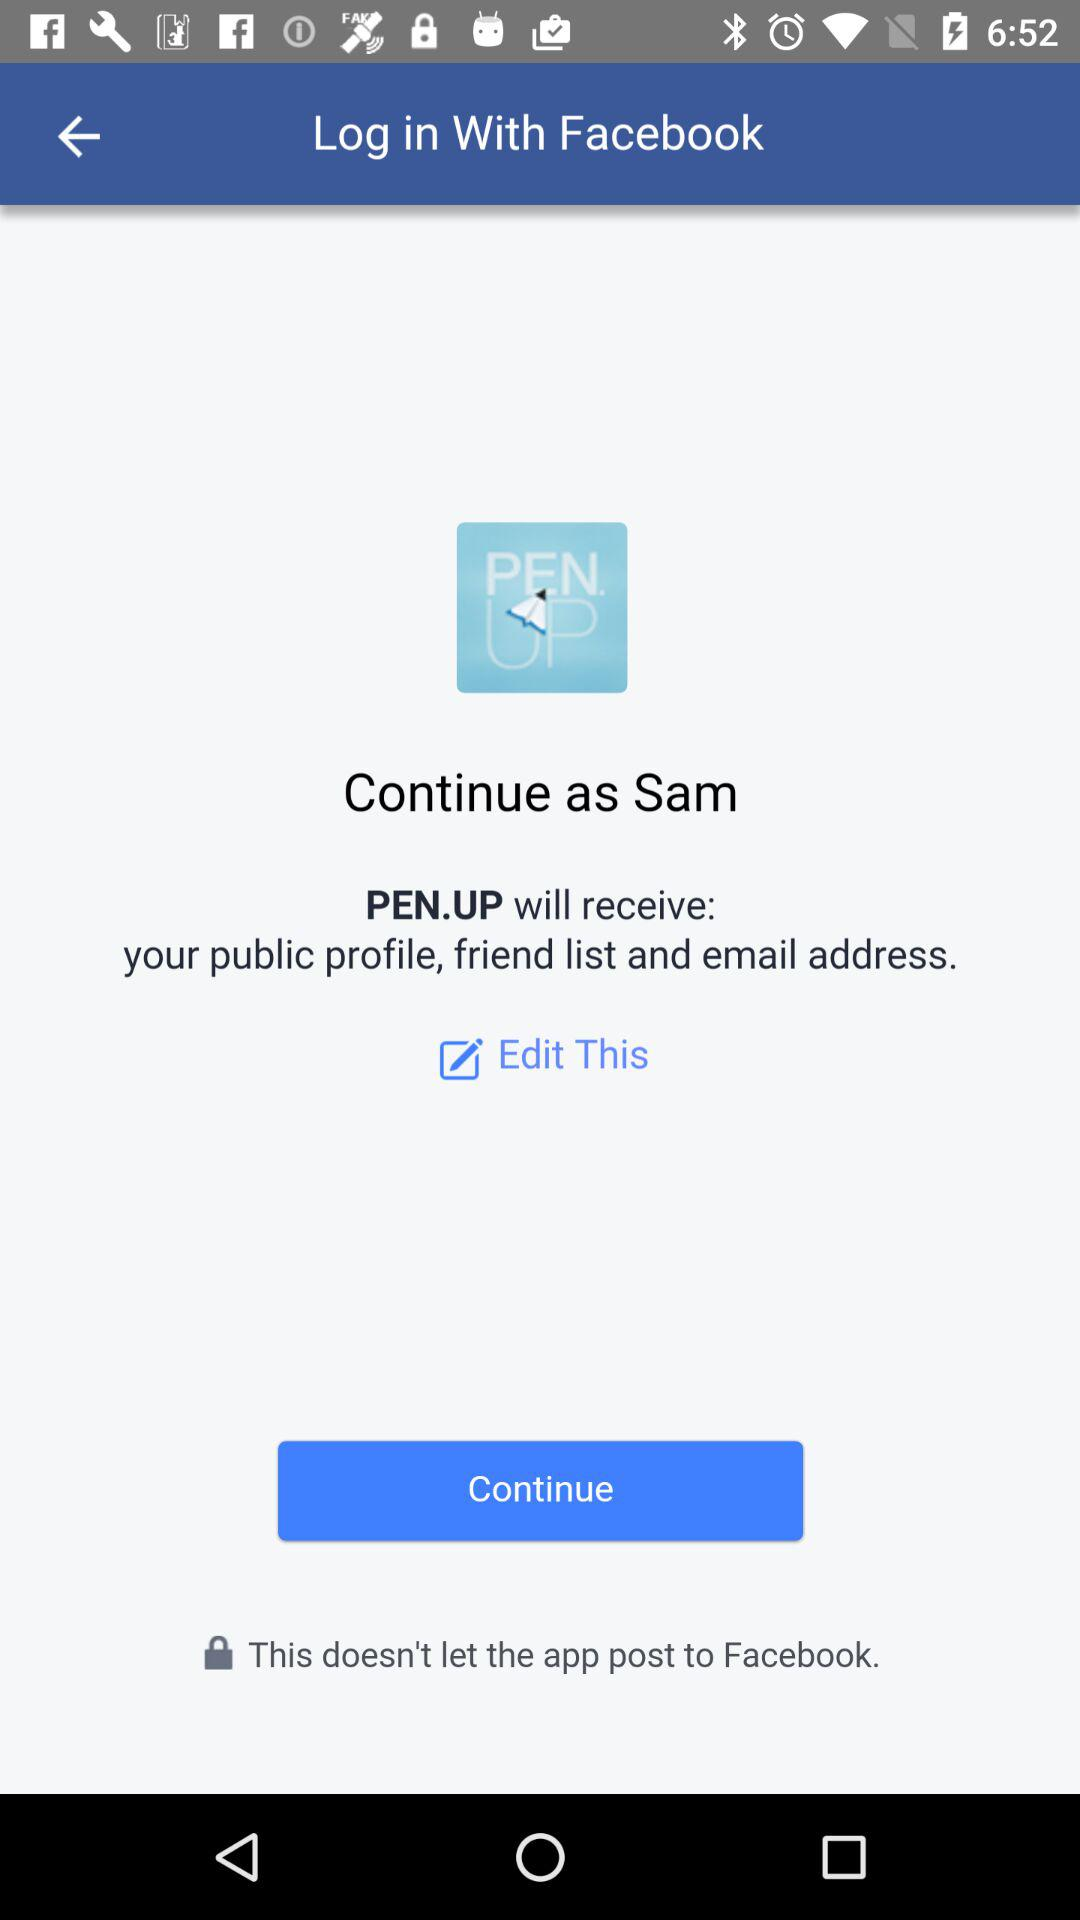Through what application can we log in? The application is "Facebook". 